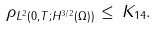<formula> <loc_0><loc_0><loc_500><loc_500>\| \rho \| _ { L ^ { 2 } ( 0 , T ; H ^ { 3 / 2 } ( \Omega ) ) } \, \leq \, K _ { 1 4 } .</formula> 